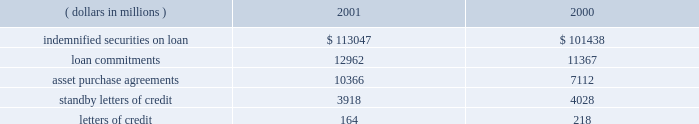Loan commitments ( unfunded loans and unused lines of credit ) , asset purchase agreements , standby letters of credit and letters of credit are issued to accommodate the financing needs of state street 2019s clients and to provide credit enhancements to special purpose entities .
Loan commitments are agreements by state street to lend monies at a future date .
Asset purchase agreements are commitments to purchase receivables or securities , subject to conditions established in the agreements , and at december 31 , 2001 , include $ 8.0 billion outstanding to special purpose entities .
Standby letters of credit and letters of credit commit state street to make payments on behalf of clients and special purpose entities when certain specified events occur .
Standby letters of credit outstanding to special purpose entities were $ 608 million at december 31 , 2001 .
These loan , asset purchase and letter of credit commitments are subject to the same credit policies and reviews as loans .
The amount and nature of collateral are obtained based upon management 2019s assessment of the credit risk .
Approximately 89% ( 89 % ) of the loan commitments and asset purchase agreements expire within one year from the date of issue .
Sincemany of the commitments are expected to expire or renewwithout being drawn , the total commitment amounts do not necessarily represent future cash requirements .
The following is a summary of the contractual amount of credit-related , off-balance sheet financial instruments at december 31: .
State street corporation 53 .
What is the percentage change in the balance of letters of credit from 2000 to 2001? 
Computations: ((164 - 218) / 218)
Answer: -0.24771. Loan commitments ( unfunded loans and unused lines of credit ) , asset purchase agreements , standby letters of credit and letters of credit are issued to accommodate the financing needs of state street 2019s clients and to provide credit enhancements to special purpose entities .
Loan commitments are agreements by state street to lend monies at a future date .
Asset purchase agreements are commitments to purchase receivables or securities , subject to conditions established in the agreements , and at december 31 , 2001 , include $ 8.0 billion outstanding to special purpose entities .
Standby letters of credit and letters of credit commit state street to make payments on behalf of clients and special purpose entities when certain specified events occur .
Standby letters of credit outstanding to special purpose entities were $ 608 million at december 31 , 2001 .
These loan , asset purchase and letter of credit commitments are subject to the same credit policies and reviews as loans .
The amount and nature of collateral are obtained based upon management 2019s assessment of the credit risk .
Approximately 89% ( 89 % ) of the loan commitments and asset purchase agreements expire within one year from the date of issue .
Sincemany of the commitments are expected to expire or renewwithout being drawn , the total commitment amounts do not necessarily represent future cash requirements .
The following is a summary of the contractual amount of credit-related , off-balance sheet financial instruments at december 31: .
State street corporation 53 .
What percent did indemnified securities on loan increase between 2000 and 2001? 
Computations: ((113047 - 101438) / 101438)
Answer: 0.11444. 